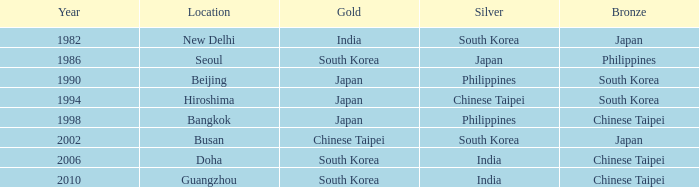Which Year is the highest one that has a Bronze of south korea, and a Silver of philippines? 1990.0. 